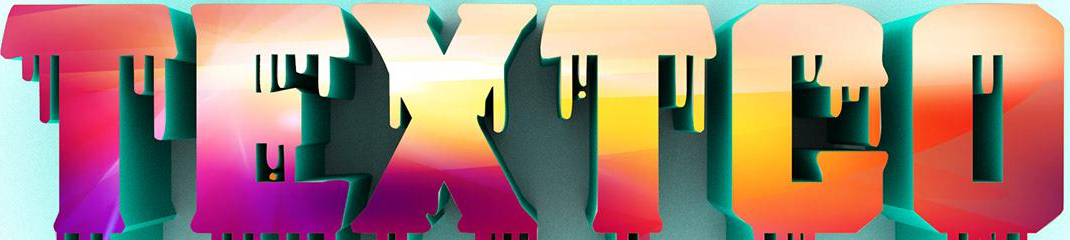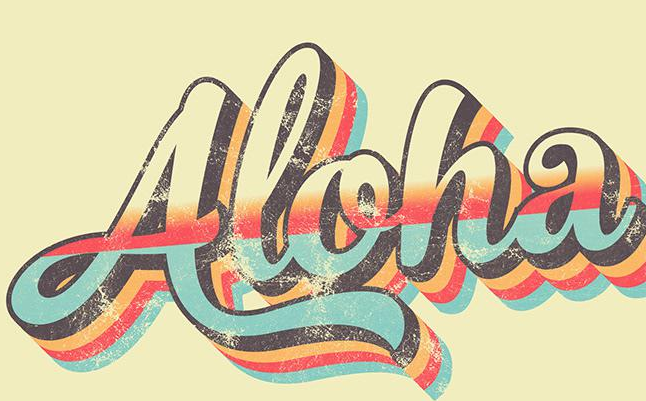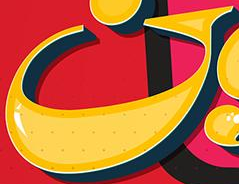What text is displayed in these images sequentially, separated by a semicolon? TEXTCO; Aloha; G 